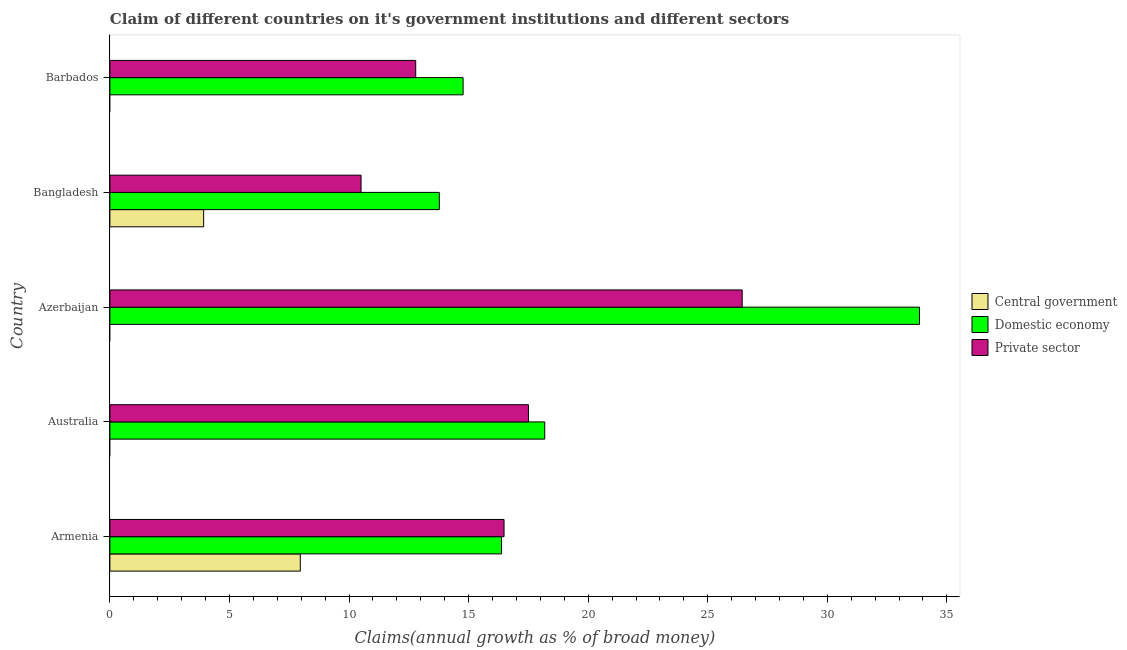How many different coloured bars are there?
Keep it short and to the point. 3. How many groups of bars are there?
Your response must be concise. 5. Are the number of bars per tick equal to the number of legend labels?
Your answer should be very brief. No. What is the label of the 2nd group of bars from the top?
Offer a very short reply. Bangladesh. In how many cases, is the number of bars for a given country not equal to the number of legend labels?
Your answer should be very brief. 3. What is the percentage of claim on the domestic economy in Bangladesh?
Your answer should be compact. 13.77. Across all countries, what is the maximum percentage of claim on the private sector?
Offer a very short reply. 26.44. Across all countries, what is the minimum percentage of claim on the central government?
Provide a short and direct response. 0. In which country was the percentage of claim on the private sector maximum?
Make the answer very short. Azerbaijan. What is the total percentage of claim on the private sector in the graph?
Make the answer very short. 83.72. What is the difference between the percentage of claim on the domestic economy in Armenia and that in Azerbaijan?
Provide a succinct answer. -17.48. What is the difference between the percentage of claim on the central government in Bangladesh and the percentage of claim on the domestic economy in Barbados?
Offer a very short reply. -10.85. What is the average percentage of claim on the private sector per country?
Offer a terse response. 16.74. What is the difference between the percentage of claim on the central government and percentage of claim on the private sector in Bangladesh?
Ensure brevity in your answer.  -6.58. In how many countries, is the percentage of claim on the central government greater than 2 %?
Keep it short and to the point. 2. What is the ratio of the percentage of claim on the private sector in Armenia to that in Barbados?
Your response must be concise. 1.29. What is the difference between the highest and the second highest percentage of claim on the private sector?
Offer a terse response. 8.94. What is the difference between the highest and the lowest percentage of claim on the domestic economy?
Provide a succinct answer. 20.08. Is it the case that in every country, the sum of the percentage of claim on the central government and percentage of claim on the domestic economy is greater than the percentage of claim on the private sector?
Ensure brevity in your answer.  Yes. How many bars are there?
Your answer should be very brief. 12. How many countries are there in the graph?
Provide a succinct answer. 5. Are the values on the major ticks of X-axis written in scientific E-notation?
Make the answer very short. No. Does the graph contain any zero values?
Provide a short and direct response. Yes. How many legend labels are there?
Offer a very short reply. 3. How are the legend labels stacked?
Ensure brevity in your answer.  Vertical. What is the title of the graph?
Provide a short and direct response. Claim of different countries on it's government institutions and different sectors. What is the label or title of the X-axis?
Your answer should be compact. Claims(annual growth as % of broad money). What is the label or title of the Y-axis?
Provide a succinct answer. Country. What is the Claims(annual growth as % of broad money) of Central government in Armenia?
Make the answer very short. 7.96. What is the Claims(annual growth as % of broad money) of Domestic economy in Armenia?
Keep it short and to the point. 16.38. What is the Claims(annual growth as % of broad money) of Private sector in Armenia?
Offer a terse response. 16.48. What is the Claims(annual growth as % of broad money) of Central government in Australia?
Your answer should be very brief. 0. What is the Claims(annual growth as % of broad money) in Domestic economy in Australia?
Offer a terse response. 18.18. What is the Claims(annual growth as % of broad money) of Private sector in Australia?
Make the answer very short. 17.5. What is the Claims(annual growth as % of broad money) of Central government in Azerbaijan?
Provide a short and direct response. 0. What is the Claims(annual growth as % of broad money) of Domestic economy in Azerbaijan?
Make the answer very short. 33.85. What is the Claims(annual growth as % of broad money) of Private sector in Azerbaijan?
Give a very brief answer. 26.44. What is the Claims(annual growth as % of broad money) of Central government in Bangladesh?
Offer a terse response. 3.92. What is the Claims(annual growth as % of broad money) of Domestic economy in Bangladesh?
Your response must be concise. 13.77. What is the Claims(annual growth as % of broad money) in Private sector in Bangladesh?
Offer a very short reply. 10.5. What is the Claims(annual growth as % of broad money) in Central government in Barbados?
Your response must be concise. 0. What is the Claims(annual growth as % of broad money) in Domestic economy in Barbados?
Your response must be concise. 14.77. What is the Claims(annual growth as % of broad money) in Private sector in Barbados?
Your answer should be very brief. 12.79. Across all countries, what is the maximum Claims(annual growth as % of broad money) in Central government?
Provide a succinct answer. 7.96. Across all countries, what is the maximum Claims(annual growth as % of broad money) of Domestic economy?
Offer a very short reply. 33.85. Across all countries, what is the maximum Claims(annual growth as % of broad money) of Private sector?
Your answer should be very brief. 26.44. Across all countries, what is the minimum Claims(annual growth as % of broad money) of Domestic economy?
Offer a very short reply. 13.77. Across all countries, what is the minimum Claims(annual growth as % of broad money) of Private sector?
Ensure brevity in your answer.  10.5. What is the total Claims(annual growth as % of broad money) in Central government in the graph?
Make the answer very short. 11.88. What is the total Claims(annual growth as % of broad money) in Domestic economy in the graph?
Offer a very short reply. 96.96. What is the total Claims(annual growth as % of broad money) of Private sector in the graph?
Your answer should be very brief. 83.72. What is the difference between the Claims(annual growth as % of broad money) in Domestic economy in Armenia and that in Australia?
Your response must be concise. -1.81. What is the difference between the Claims(annual growth as % of broad money) of Private sector in Armenia and that in Australia?
Your answer should be compact. -1.02. What is the difference between the Claims(annual growth as % of broad money) of Domestic economy in Armenia and that in Azerbaijan?
Your response must be concise. -17.48. What is the difference between the Claims(annual growth as % of broad money) in Private sector in Armenia and that in Azerbaijan?
Offer a very short reply. -9.96. What is the difference between the Claims(annual growth as % of broad money) in Central government in Armenia and that in Bangladesh?
Provide a succinct answer. 4.04. What is the difference between the Claims(annual growth as % of broad money) of Domestic economy in Armenia and that in Bangladesh?
Ensure brevity in your answer.  2.6. What is the difference between the Claims(annual growth as % of broad money) of Private sector in Armenia and that in Bangladesh?
Provide a short and direct response. 5.98. What is the difference between the Claims(annual growth as % of broad money) in Domestic economy in Armenia and that in Barbados?
Provide a short and direct response. 1.61. What is the difference between the Claims(annual growth as % of broad money) in Private sector in Armenia and that in Barbados?
Provide a short and direct response. 3.69. What is the difference between the Claims(annual growth as % of broad money) in Domestic economy in Australia and that in Azerbaijan?
Provide a succinct answer. -15.67. What is the difference between the Claims(annual growth as % of broad money) in Private sector in Australia and that in Azerbaijan?
Provide a succinct answer. -8.94. What is the difference between the Claims(annual growth as % of broad money) of Domestic economy in Australia and that in Bangladesh?
Provide a short and direct response. 4.41. What is the difference between the Claims(annual growth as % of broad money) in Private sector in Australia and that in Bangladesh?
Your answer should be very brief. 7. What is the difference between the Claims(annual growth as % of broad money) in Domestic economy in Australia and that in Barbados?
Provide a succinct answer. 3.41. What is the difference between the Claims(annual growth as % of broad money) of Private sector in Australia and that in Barbados?
Your response must be concise. 4.71. What is the difference between the Claims(annual growth as % of broad money) of Domestic economy in Azerbaijan and that in Bangladesh?
Keep it short and to the point. 20.08. What is the difference between the Claims(annual growth as % of broad money) of Private sector in Azerbaijan and that in Bangladesh?
Give a very brief answer. 15.94. What is the difference between the Claims(annual growth as % of broad money) of Domestic economy in Azerbaijan and that in Barbados?
Keep it short and to the point. 19.08. What is the difference between the Claims(annual growth as % of broad money) of Private sector in Azerbaijan and that in Barbados?
Ensure brevity in your answer.  13.65. What is the difference between the Claims(annual growth as % of broad money) of Domestic economy in Bangladesh and that in Barbados?
Give a very brief answer. -1. What is the difference between the Claims(annual growth as % of broad money) in Private sector in Bangladesh and that in Barbados?
Your answer should be compact. -2.29. What is the difference between the Claims(annual growth as % of broad money) of Central government in Armenia and the Claims(annual growth as % of broad money) of Domestic economy in Australia?
Provide a succinct answer. -10.22. What is the difference between the Claims(annual growth as % of broad money) in Central government in Armenia and the Claims(annual growth as % of broad money) in Private sector in Australia?
Provide a succinct answer. -9.54. What is the difference between the Claims(annual growth as % of broad money) of Domestic economy in Armenia and the Claims(annual growth as % of broad money) of Private sector in Australia?
Your answer should be very brief. -1.13. What is the difference between the Claims(annual growth as % of broad money) in Central government in Armenia and the Claims(annual growth as % of broad money) in Domestic economy in Azerbaijan?
Your response must be concise. -25.89. What is the difference between the Claims(annual growth as % of broad money) of Central government in Armenia and the Claims(annual growth as % of broad money) of Private sector in Azerbaijan?
Your response must be concise. -18.48. What is the difference between the Claims(annual growth as % of broad money) in Domestic economy in Armenia and the Claims(annual growth as % of broad money) in Private sector in Azerbaijan?
Your answer should be compact. -10.06. What is the difference between the Claims(annual growth as % of broad money) in Central government in Armenia and the Claims(annual growth as % of broad money) in Domestic economy in Bangladesh?
Keep it short and to the point. -5.81. What is the difference between the Claims(annual growth as % of broad money) of Central government in Armenia and the Claims(annual growth as % of broad money) of Private sector in Bangladesh?
Provide a succinct answer. -2.54. What is the difference between the Claims(annual growth as % of broad money) of Domestic economy in Armenia and the Claims(annual growth as % of broad money) of Private sector in Bangladesh?
Offer a terse response. 5.87. What is the difference between the Claims(annual growth as % of broad money) of Central government in Armenia and the Claims(annual growth as % of broad money) of Domestic economy in Barbados?
Offer a terse response. -6.81. What is the difference between the Claims(annual growth as % of broad money) of Central government in Armenia and the Claims(annual growth as % of broad money) of Private sector in Barbados?
Offer a very short reply. -4.83. What is the difference between the Claims(annual growth as % of broad money) in Domestic economy in Armenia and the Claims(annual growth as % of broad money) in Private sector in Barbados?
Give a very brief answer. 3.59. What is the difference between the Claims(annual growth as % of broad money) of Domestic economy in Australia and the Claims(annual growth as % of broad money) of Private sector in Azerbaijan?
Your response must be concise. -8.26. What is the difference between the Claims(annual growth as % of broad money) of Domestic economy in Australia and the Claims(annual growth as % of broad money) of Private sector in Bangladesh?
Keep it short and to the point. 7.68. What is the difference between the Claims(annual growth as % of broad money) of Domestic economy in Australia and the Claims(annual growth as % of broad money) of Private sector in Barbados?
Offer a terse response. 5.39. What is the difference between the Claims(annual growth as % of broad money) of Domestic economy in Azerbaijan and the Claims(annual growth as % of broad money) of Private sector in Bangladesh?
Give a very brief answer. 23.35. What is the difference between the Claims(annual growth as % of broad money) in Domestic economy in Azerbaijan and the Claims(annual growth as % of broad money) in Private sector in Barbados?
Your answer should be very brief. 21.07. What is the difference between the Claims(annual growth as % of broad money) of Central government in Bangladesh and the Claims(annual growth as % of broad money) of Domestic economy in Barbados?
Your answer should be very brief. -10.85. What is the difference between the Claims(annual growth as % of broad money) of Central government in Bangladesh and the Claims(annual growth as % of broad money) of Private sector in Barbados?
Make the answer very short. -8.87. What is the average Claims(annual growth as % of broad money) in Central government per country?
Make the answer very short. 2.38. What is the average Claims(annual growth as % of broad money) of Domestic economy per country?
Offer a terse response. 19.39. What is the average Claims(annual growth as % of broad money) in Private sector per country?
Keep it short and to the point. 16.74. What is the difference between the Claims(annual growth as % of broad money) of Central government and Claims(annual growth as % of broad money) of Domestic economy in Armenia?
Your response must be concise. -8.41. What is the difference between the Claims(annual growth as % of broad money) in Central government and Claims(annual growth as % of broad money) in Private sector in Armenia?
Give a very brief answer. -8.52. What is the difference between the Claims(annual growth as % of broad money) in Domestic economy and Claims(annual growth as % of broad money) in Private sector in Armenia?
Ensure brevity in your answer.  -0.11. What is the difference between the Claims(annual growth as % of broad money) of Domestic economy and Claims(annual growth as % of broad money) of Private sector in Australia?
Ensure brevity in your answer.  0.68. What is the difference between the Claims(annual growth as % of broad money) of Domestic economy and Claims(annual growth as % of broad money) of Private sector in Azerbaijan?
Give a very brief answer. 7.41. What is the difference between the Claims(annual growth as % of broad money) in Central government and Claims(annual growth as % of broad money) in Domestic economy in Bangladesh?
Offer a very short reply. -9.85. What is the difference between the Claims(annual growth as % of broad money) in Central government and Claims(annual growth as % of broad money) in Private sector in Bangladesh?
Ensure brevity in your answer.  -6.58. What is the difference between the Claims(annual growth as % of broad money) of Domestic economy and Claims(annual growth as % of broad money) of Private sector in Bangladesh?
Offer a terse response. 3.27. What is the difference between the Claims(annual growth as % of broad money) in Domestic economy and Claims(annual growth as % of broad money) in Private sector in Barbados?
Keep it short and to the point. 1.98. What is the ratio of the Claims(annual growth as % of broad money) in Domestic economy in Armenia to that in Australia?
Make the answer very short. 0.9. What is the ratio of the Claims(annual growth as % of broad money) in Private sector in Armenia to that in Australia?
Provide a succinct answer. 0.94. What is the ratio of the Claims(annual growth as % of broad money) in Domestic economy in Armenia to that in Azerbaijan?
Your answer should be compact. 0.48. What is the ratio of the Claims(annual growth as % of broad money) in Private sector in Armenia to that in Azerbaijan?
Your response must be concise. 0.62. What is the ratio of the Claims(annual growth as % of broad money) in Central government in Armenia to that in Bangladesh?
Your answer should be compact. 2.03. What is the ratio of the Claims(annual growth as % of broad money) in Domestic economy in Armenia to that in Bangladesh?
Offer a very short reply. 1.19. What is the ratio of the Claims(annual growth as % of broad money) of Private sector in Armenia to that in Bangladesh?
Make the answer very short. 1.57. What is the ratio of the Claims(annual growth as % of broad money) in Domestic economy in Armenia to that in Barbados?
Provide a short and direct response. 1.11. What is the ratio of the Claims(annual growth as % of broad money) in Private sector in Armenia to that in Barbados?
Make the answer very short. 1.29. What is the ratio of the Claims(annual growth as % of broad money) in Domestic economy in Australia to that in Azerbaijan?
Your answer should be compact. 0.54. What is the ratio of the Claims(annual growth as % of broad money) in Private sector in Australia to that in Azerbaijan?
Provide a succinct answer. 0.66. What is the ratio of the Claims(annual growth as % of broad money) of Domestic economy in Australia to that in Bangladesh?
Offer a terse response. 1.32. What is the ratio of the Claims(annual growth as % of broad money) in Private sector in Australia to that in Bangladesh?
Keep it short and to the point. 1.67. What is the ratio of the Claims(annual growth as % of broad money) of Domestic economy in Australia to that in Barbados?
Offer a terse response. 1.23. What is the ratio of the Claims(annual growth as % of broad money) of Private sector in Australia to that in Barbados?
Offer a terse response. 1.37. What is the ratio of the Claims(annual growth as % of broad money) in Domestic economy in Azerbaijan to that in Bangladesh?
Provide a short and direct response. 2.46. What is the ratio of the Claims(annual growth as % of broad money) of Private sector in Azerbaijan to that in Bangladesh?
Make the answer very short. 2.52. What is the ratio of the Claims(annual growth as % of broad money) of Domestic economy in Azerbaijan to that in Barbados?
Your response must be concise. 2.29. What is the ratio of the Claims(annual growth as % of broad money) in Private sector in Azerbaijan to that in Barbados?
Keep it short and to the point. 2.07. What is the ratio of the Claims(annual growth as % of broad money) in Domestic economy in Bangladesh to that in Barbados?
Your response must be concise. 0.93. What is the ratio of the Claims(annual growth as % of broad money) of Private sector in Bangladesh to that in Barbados?
Offer a terse response. 0.82. What is the difference between the highest and the second highest Claims(annual growth as % of broad money) in Domestic economy?
Ensure brevity in your answer.  15.67. What is the difference between the highest and the second highest Claims(annual growth as % of broad money) in Private sector?
Provide a short and direct response. 8.94. What is the difference between the highest and the lowest Claims(annual growth as % of broad money) of Central government?
Ensure brevity in your answer.  7.96. What is the difference between the highest and the lowest Claims(annual growth as % of broad money) in Domestic economy?
Ensure brevity in your answer.  20.08. What is the difference between the highest and the lowest Claims(annual growth as % of broad money) of Private sector?
Offer a terse response. 15.94. 